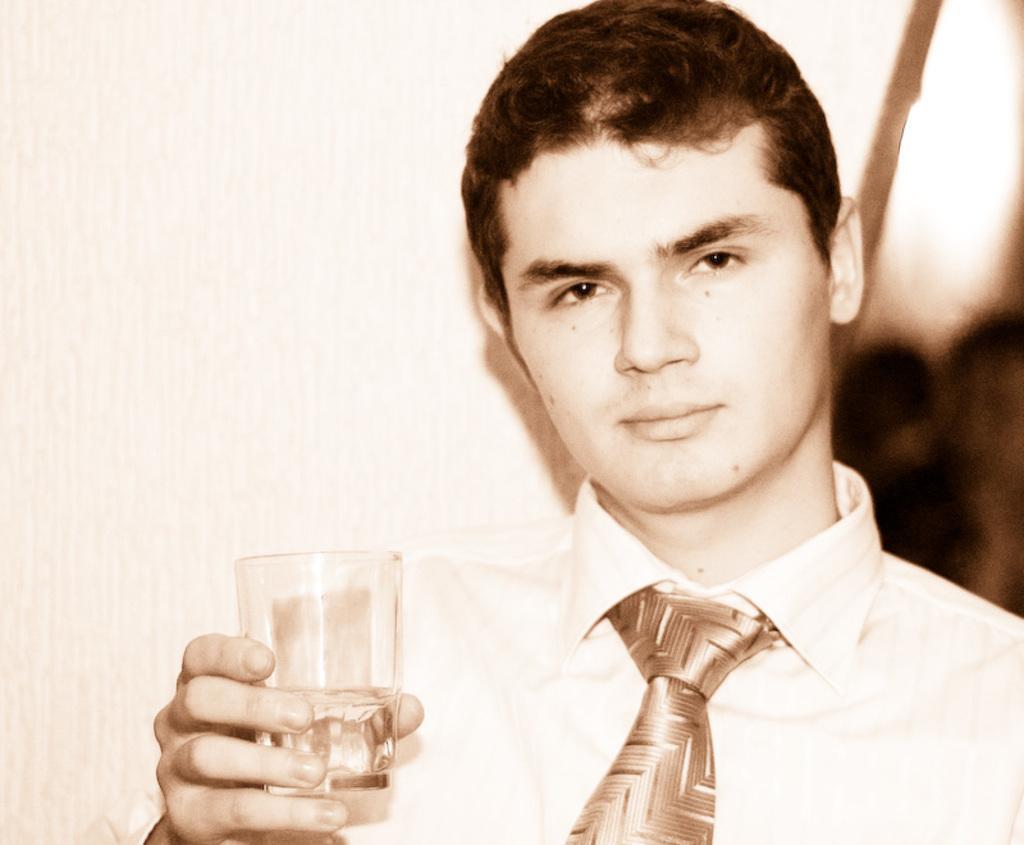Please provide a concise description of this image. In this image we can see a man holding a glass. In the background there is a wall. 